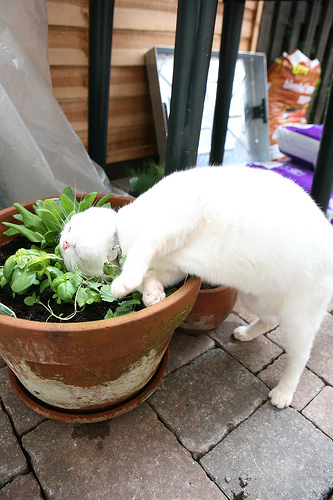What is in the pot? There is a plant inside the pot. 